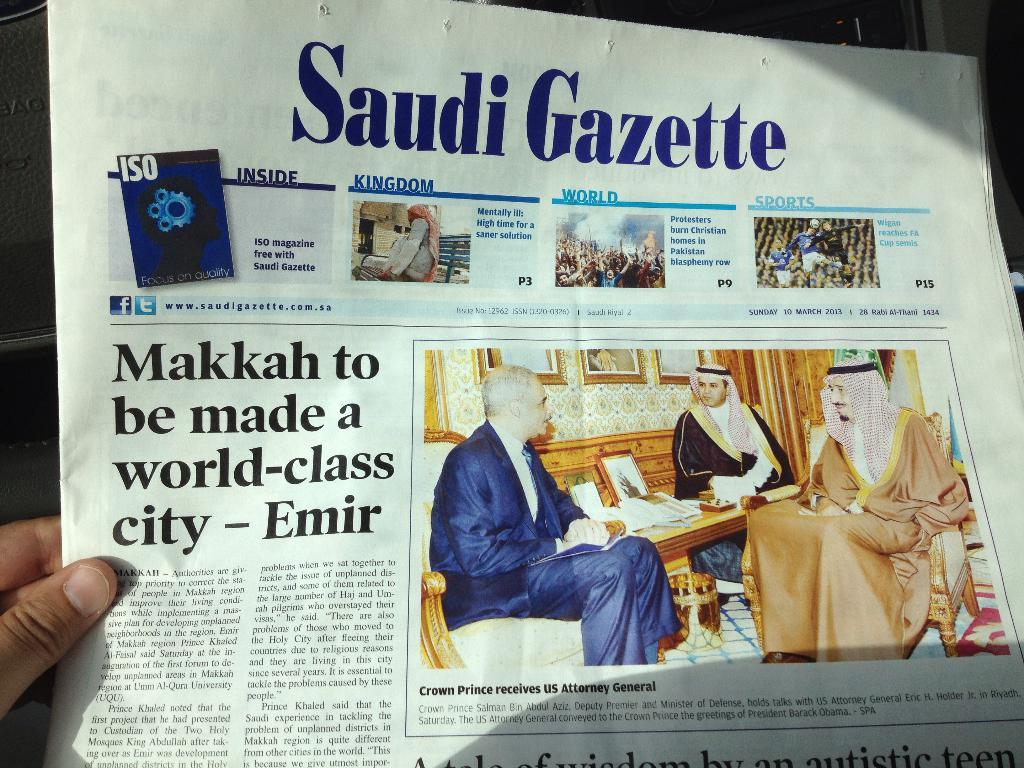What object can be seen in the image that is used for reading? There is a newspaper in the image that can be used for reading. How many Arab women are present in the image? There are two Arab women in the image. What is the man in the image wearing? The man in the image is wearing a suit. Where is the man sitting in the image? The man is sitting on a sofa. What is written on the newspaper in the image? The newspaper has text on it. Can you see a loaf of bread being used as a toy by the man in the image? There is no loaf of bread or toy present in the image. How does the man jump over the sofa in the image? The man does not jump over the sofa in the image; he is sitting on it. 